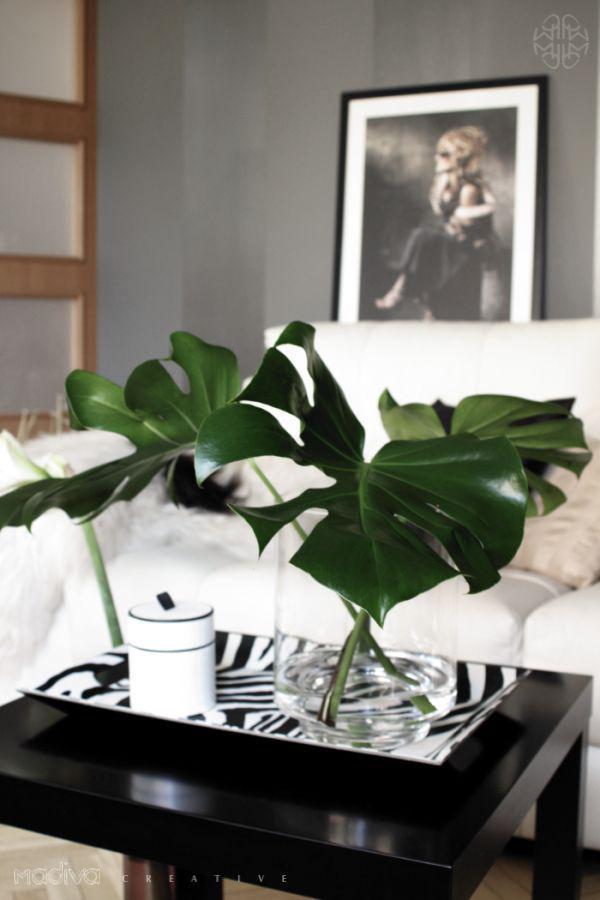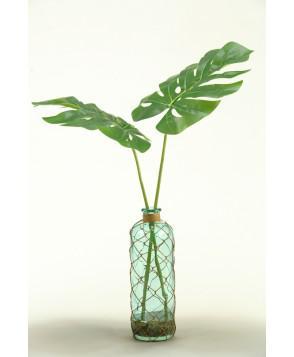The first image is the image on the left, the second image is the image on the right. Examine the images to the left and right. Is the description "In one image, a clear glass vase contains three stems of shiny, wide, dark green leaves that are arranged with each leaning in a different direction." accurate? Answer yes or no. Yes. The first image is the image on the left, the second image is the image on the right. For the images displayed, is the sentence "The right image includes a vase holding green fronds that don't have spiky grass-like leaves." factually correct? Answer yes or no. Yes. 